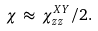<formula> <loc_0><loc_0><loc_500><loc_500>\chi \, \approx \, \chi ^ { X Y } _ { z z } / 2 .</formula> 